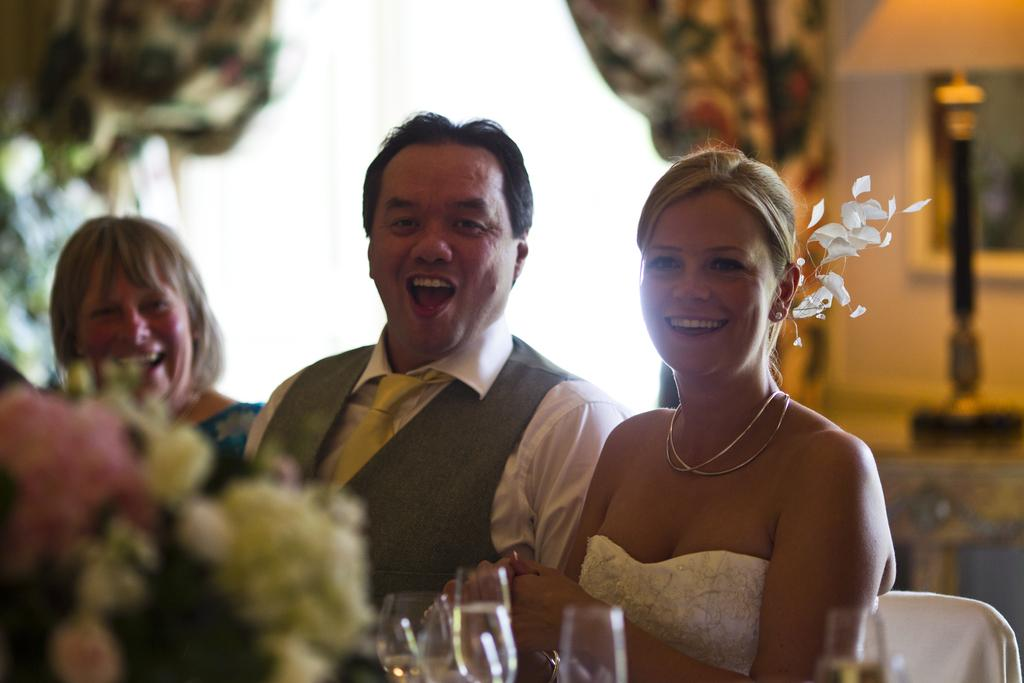How many people are in the image? There are three persons in the image. What are the persons doing in the image? The persons are sitting on chairs. What objects can be seen in the image besides the persons? There are glasses and a flower bouquet in the image. What is visible in the background of the image? There is a wall in the background of the image. What type of string is being played by the friend in the image? There is no friend or string present in the image; it features three persons sitting on chairs. What role does the minister play in the image? There is no minister present in the image; it features three persons sitting on chairs, glasses, a flower bouquet, and a wall in the background. 